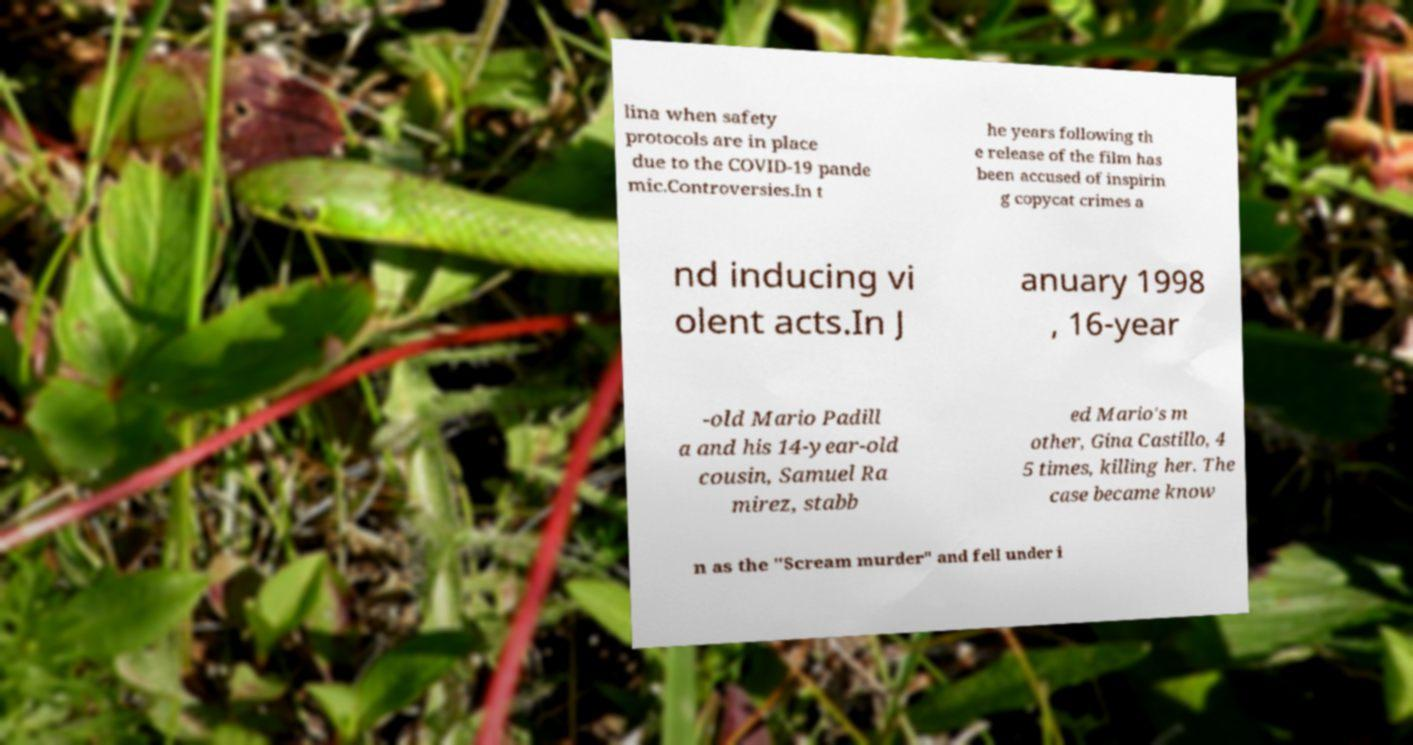Could you extract and type out the text from this image? lina when safety protocols are in place due to the COVID-19 pande mic.Controversies.In t he years following th e release of the film has been accused of inspirin g copycat crimes a nd inducing vi olent acts.In J anuary 1998 , 16-year -old Mario Padill a and his 14-year-old cousin, Samuel Ra mirez, stabb ed Mario's m other, Gina Castillo, 4 5 times, killing her. The case became know n as the "Scream murder" and fell under i 